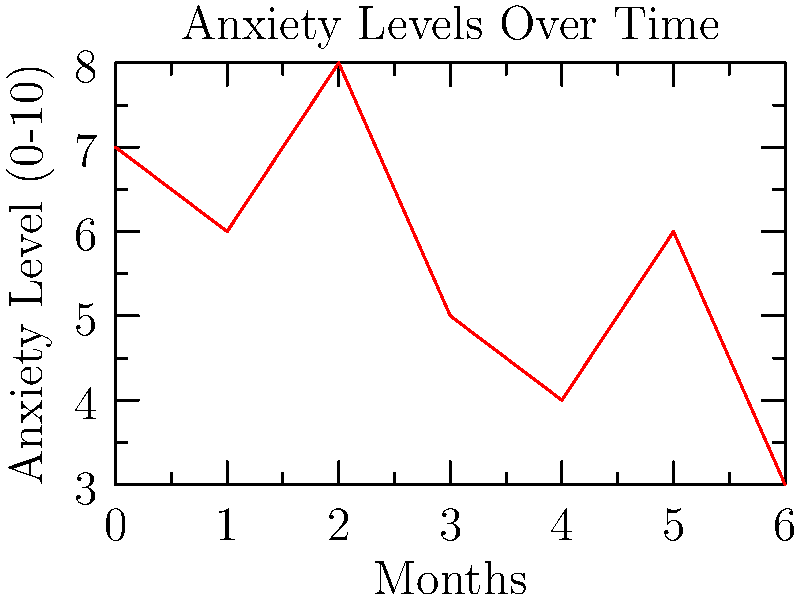As part of your therapy for mild general anxiety disorder, you've been tracking your anxiety levels on a scale of 0-10 over the past 6 months. The line graph shows your recorded anxiety levels. What is the overall trend of your anxiety levels, and what is the difference between your highest and lowest recorded levels? To answer this question, let's analyze the graph step-by-step:

1. Overall trend:
   - Look at the general direction of the line from left to right.
   - The line starts at 7, fluctuates, but ends at 3.
   - This indicates a general downward trend in anxiety levels over time.

2. Highest and lowest recorded levels:
   - Scan the graph to find the highest point: 8 (at month 2)
   - Scan the graph to find the lowest point: 3 (at month 6)
   - Calculate the difference: $8 - 3 = 5$

Therefore, the overall trend is decreasing, and the difference between the highest and lowest recorded levels is 5.
Answer: Decreasing trend; 5-point difference 